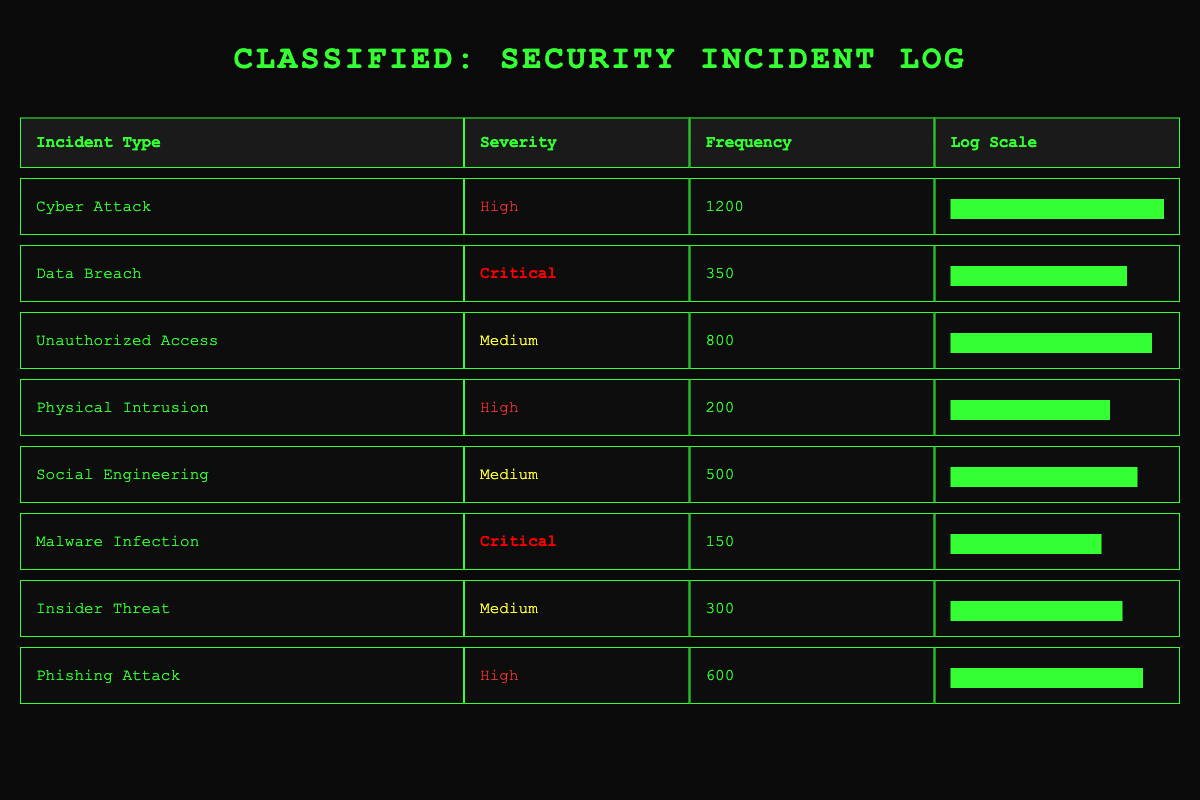What is the frequency of Cyber Attack incidents? The table lists Cyber Attack incidents with a frequency of 1200.
Answer: 1200 Which incident type has the highest severity? The highest severity in the table is Critical, which corresponds to Data Breach and Malware Infection.
Answer: Data Breach and Malware Infection What is the total frequency of Medium severity incidents? The Medium severity incidents are Unauthorized Access (800), Social Engineering (500), and Insider Threat (300). Adding these gives 800 + 500 + 300 = 1600.
Answer: 1600 Is the frequency of Phishing Attacks greater than that of Physical Intrusion? The frequency for Phishing Attacks is 600, while Physical Intrusion has a frequency of 200. Since 600 > 200, the statement is true.
Answer: Yes Which incident types have a frequency less than 400? The incident types with frequencies less than 400 are Malware Infection (150) and Physical Intrusion (200).
Answer: Malware Infection and Physical Intrusion What is the average frequency of all incidents with High severity? There are three incidents with High severity: Cyber Attack (1200), Physical Intrusion (200), and Phishing Attack (600). To find the average, sum these (1200 + 200 + 600 = 2000) and divide by 3, which gives 2000 / 3 = 666.67.
Answer: 666.67 What percentage of incidents categorized as Critical occurred compared to the total frequency of all incidents? The total frequency of all incidents is 1200 + 350 + 800 + 200 + 500 + 150 + 300 + 600 = 3100. The critical incidents (Data Breach + Malware Infection) have a total frequency of 350 + 150 = 500. To find the percentage, divide 500 by 3100 and multiply by 100, giving (500 / 3100) * 100 = approximately 16.13%.
Answer: 16.13% How many more Cyber Attack incidents occurred than Malware Infections? The table shows 1200 Cyber Attack incidents and 150 Malware Infections. To find the difference, subtract Malware Infections from Cyber Attacks: 1200 - 150 = 1050.
Answer: 1050 Which incident type has a frequency closest to the average across all incidents? First, sum the frequencies: 3100, then divide by 8 (the number of incident types), yielding an average of 387.5. The closest frequencies are that of Insider Threat (300) and Data Breach (350).
Answer: Insider Threat and Data Breach 